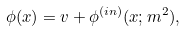<formula> <loc_0><loc_0><loc_500><loc_500>\phi ( x ) = v + \phi ^ { ( i n ) } ( x ; m ^ { 2 } ) ,</formula> 